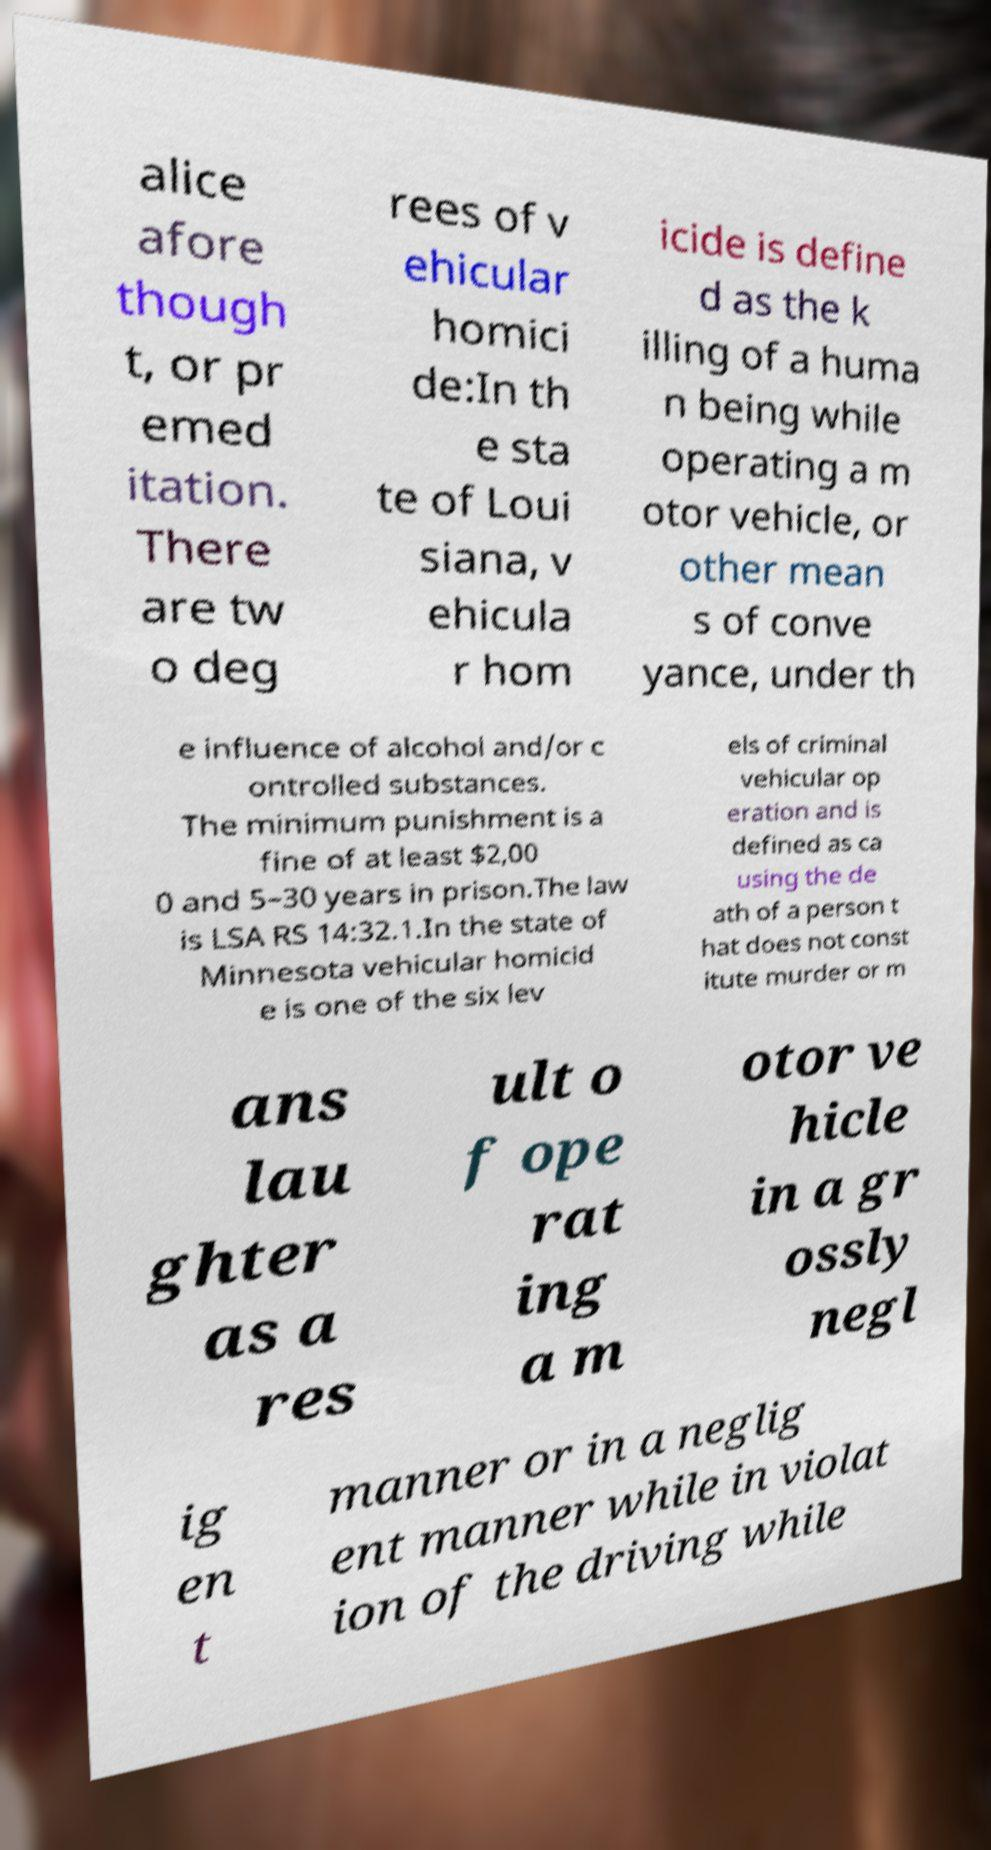Please read and relay the text visible in this image. What does it say? alice afore though t, or pr emed itation. There are tw o deg rees of v ehicular homici de:In th e sta te of Loui siana, v ehicula r hom icide is define d as the k illing of a huma n being while operating a m otor vehicle, or other mean s of conve yance, under th e influence of alcohol and/or c ontrolled substances. The minimum punishment is a fine of at least $2,00 0 and 5–30 years in prison.The law is LSA RS 14:32.1.In the state of Minnesota vehicular homicid e is one of the six lev els of criminal vehicular op eration and is defined as ca using the de ath of a person t hat does not const itute murder or m ans lau ghter as a res ult o f ope rat ing a m otor ve hicle in a gr ossly negl ig en t manner or in a neglig ent manner while in violat ion of the driving while 